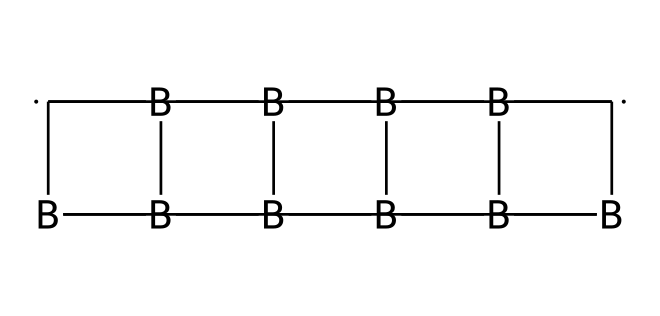What is the primary element in the structure? The chemical structure contains boron and carbon atoms, but the primary element is boron, as it appears multiple times and is central to the cage structure.
Answer: boron How many carbon atoms are present in the compound? By examining the structure, we identify seven carbon atoms that are represented in the SMILES. The carbon atoms are associated with the boron in the cage-like configuration.
Answer: seven What type of molecular geometry do carboranes exhibit? Carboranes typically exhibit a polyhedral geometry due to their cage-like structure formed by the arrangement of boron and carbon atoms.
Answer: polyhedral Can this compound be classified as an organoboron compound? Since the compound contains carbon atoms bonded to boron, it fits the definition of an organoboron compound, thus affirming its classification.
Answer: yes How many boron atoms are in the structure? The SMILES notation indicates a total of six boron atoms in the chemical structure. Each boron is critical to forming the cage structure.
Answer: six What is the role of carboranes in medicine? Carboranes are particularly used in neutron capture therapy, as they can effectively capture neutrons and release energy to target cancer cells.
Answer: cancer treatment 